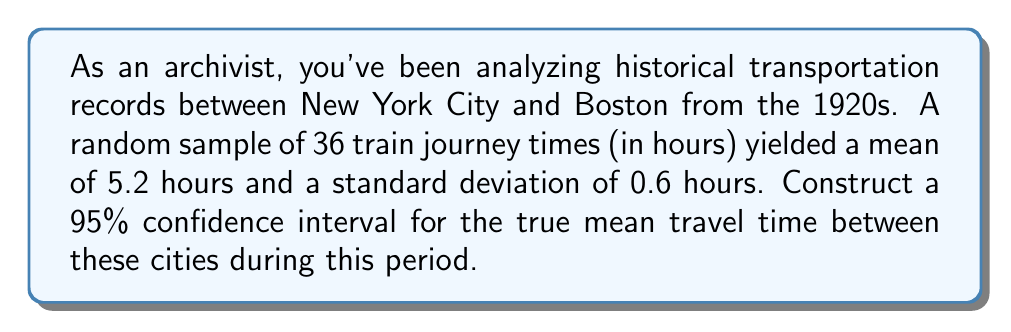Give your solution to this math problem. Let's construct the confidence interval step-by-step:

1) We're given:
   - Sample size: $n = 36$
   - Sample mean: $\bar{x} = 5.2$ hours
   - Sample standard deviation: $s = 0.6$ hours
   - Confidence level: 95%

2) The formula for a confidence interval is:

   $$\bar{x} \pm t_{\alpha/2} \cdot \frac{s}{\sqrt{n}}$$

   where $t_{\alpha/2}$ is the t-value from the t-distribution with $n-1$ degrees of freedom.

3) For a 95% confidence interval, $\alpha = 0.05$, and $\alpha/2 = 0.025$

4) Degrees of freedom: $df = n - 1 = 36 - 1 = 35$

5) From the t-distribution table, $t_{0.025,35} \approx 2.030$

6) Now, let's calculate the margin of error:

   $$\text{Margin of Error} = t_{\alpha/2} \cdot \frac{s}{\sqrt{n}} = 2.030 \cdot \frac{0.6}{\sqrt{36}} = 2.030 \cdot 0.1 = 0.203$$

7) Finally, we can construct the confidence interval:

   $$5.2 \pm 0.203$$

   Lower bound: $5.2 - 0.203 = 4.997$
   Upper bound: $5.2 + 0.203 = 5.403$

Therefore, we are 95% confident that the true mean travel time between New York City and Boston in the 1920s falls between 4.997 and 5.403 hours.
Answer: (4.997, 5.403) hours 